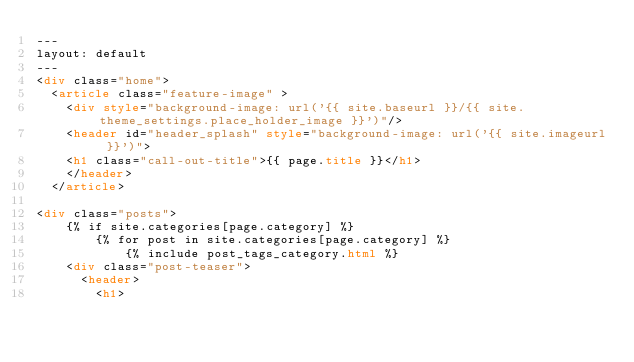Convert code to text. <code><loc_0><loc_0><loc_500><loc_500><_HTML_>---
layout: default
---
<div class="home">
  <article class="feature-image" >
  	<div style="background-image: url('{{ site.baseurl }}/{{ site.theme_settings.place_holder_image }}')"/>
  	<header id="header_splash" style="background-image: url('{{ site.imageurl }}')">
    <h1 class="call-out-title">{{ page.title }}</h1>
    </header>
  </article>

<div class="posts">
    {% if site.categories[page.category] %}
        {% for post in site.categories[page.category] %}
            {% include post_tags_category.html %}
		<div class="post-teaser">
		  <header>
		    <h1></code> 